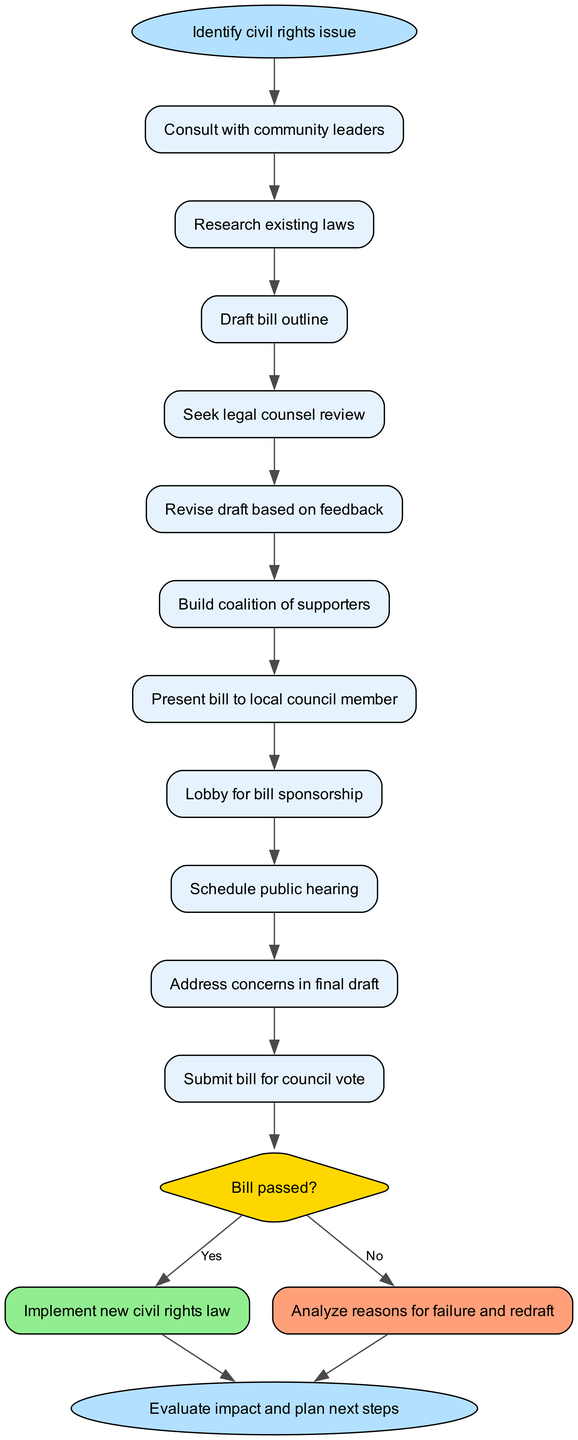What is the first step in drafting the civil rights bill? The diagram indicates that the first step is to "Identify civil rights issue." This is the initial action taken before any subsequent steps can occur.
Answer: Identify civil rights issue How many steps are there in the process? Upon reviewing the diagram, you can count a total of 11 steps, including the start and end nodes. This involves the comprehensive actions outlined before reaching the decision node.
Answer: 11 What is the decision point in the process? The decision point identified in the diagram is a diamond-shaped node labeled "Bill passed?" This indicates a critical juncture in determining the success of the bill based on the council's vote.
Answer: Bill passed? What happens if the bill is passed? According to the diagram, if the bill is passed, the next step is to "Implement new civil rights law." This shows the outcome of a successful voting process for the proposed bill.
Answer: Implement new civil rights law What is the last step in this process? By tracing the flow to the end of the diagram, the last step is "Evaluate impact and plan next steps." This signifies a reflective action after the bill's implementation and its effects.
Answer: Evaluate impact and plan next steps What must be done after presenting the bill to a local council member? After presenting the bill to the local council member, the subsequent action is to "Lobby for bill sponsorship." This indicates the continuation of efforts to gain support for the bill.
Answer: Lobby for bill sponsorship How many possible outcomes are there after the decision point? The diagram reveals two possible outcomes after the decision node, which are "Yes" and "No." This illustrates the binary nature of the decision regarding the bill's passage.
Answer: 2 What is required for the bill draft based on feedback? The flow chart shows that after seeking legal counsel review, the bill draft must be "Revise draft based on feedback." This suggests that modifications are essential for improvement.
Answer: Revise draft based on feedback What action follows after addressing concerns in the final draft? Following the action of addressing concerns in the final draft, the next step according to the diagram is to "Submit bill for council vote." This indicates the movement toward formal consideration by the council.
Answer: Submit bill for council vote 